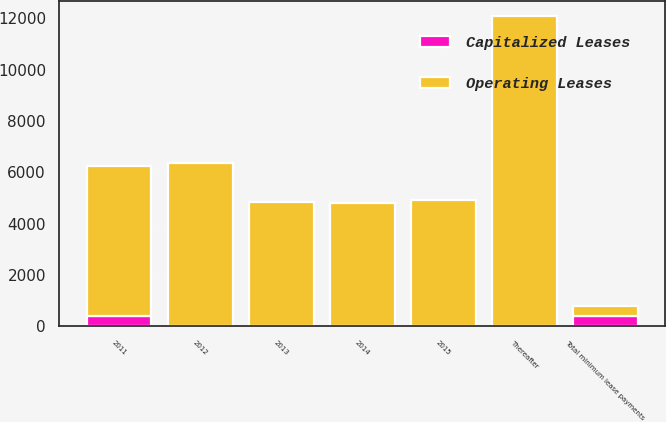Convert chart. <chart><loc_0><loc_0><loc_500><loc_500><stacked_bar_chart><ecel><fcel>2011<fcel>2012<fcel>2013<fcel>2014<fcel>2015<fcel>Thereafter<fcel>Total minimum lease payments<nl><fcel>Capitalized Leases<fcel>395<fcel>0<fcel>0<fcel>0<fcel>0<fcel>0<fcel>395<nl><fcel>Operating Leases<fcel>5843<fcel>6362<fcel>4854<fcel>4797<fcel>4935<fcel>12093<fcel>395<nl></chart> 